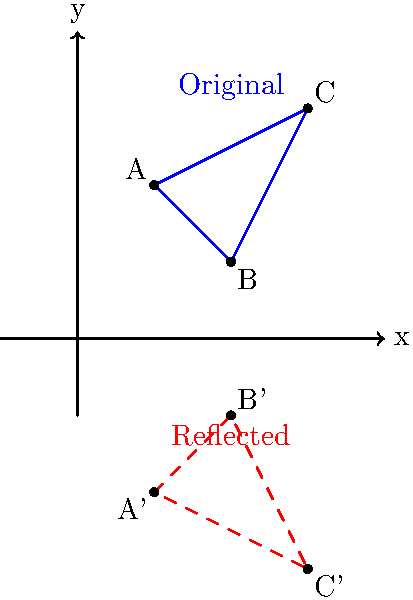In a dramatic scene, you want to create a mirror effect by reflecting a character's silhouette across the x-axis. The character's silhouette is represented by triangle ABC with coordinates A(1,2), B(2,1), and C(3,3). What are the coordinates of point A' in the reflected silhouette? To find the coordinates of point A' in the reflected silhouette, we need to follow these steps:

1. Identify the original coordinates of point A: (1,2)

2. Understand the reflection rule across the x-axis:
   When reflecting a point across the x-axis, the x-coordinate remains the same, while the y-coordinate changes sign.

3. Apply the reflection rule to point A:
   - The x-coordinate stays the same: 1
   - The y-coordinate changes sign: 2 becomes -2

4. Write the new coordinates for A':
   A' will have coordinates (1, -2)

This process creates a mirror image of the original silhouette, with the x-axis acting as the "mirror". The entire triangle ABC will be reflected to create A'B'C', producing a dramatic mirror effect for the scene.
Answer: (1, -2) 